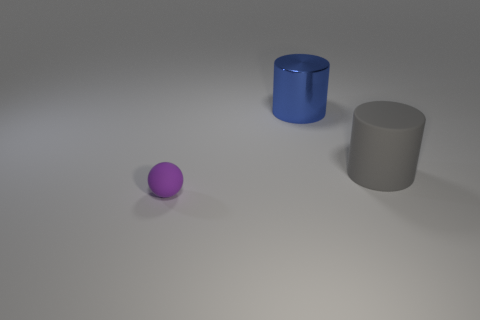Add 3 small purple rubber things. How many objects exist? 6 Subtract all spheres. How many objects are left? 2 Subtract 1 cylinders. How many cylinders are left? 1 Subtract all yellow balls. Subtract all blue cubes. How many balls are left? 1 Subtract all gray blocks. How many gray cylinders are left? 1 Add 2 large blue cylinders. How many large blue cylinders are left? 3 Add 3 small brown balls. How many small brown balls exist? 3 Subtract 0 cyan blocks. How many objects are left? 3 Subtract all large matte objects. Subtract all large blue metal objects. How many objects are left? 1 